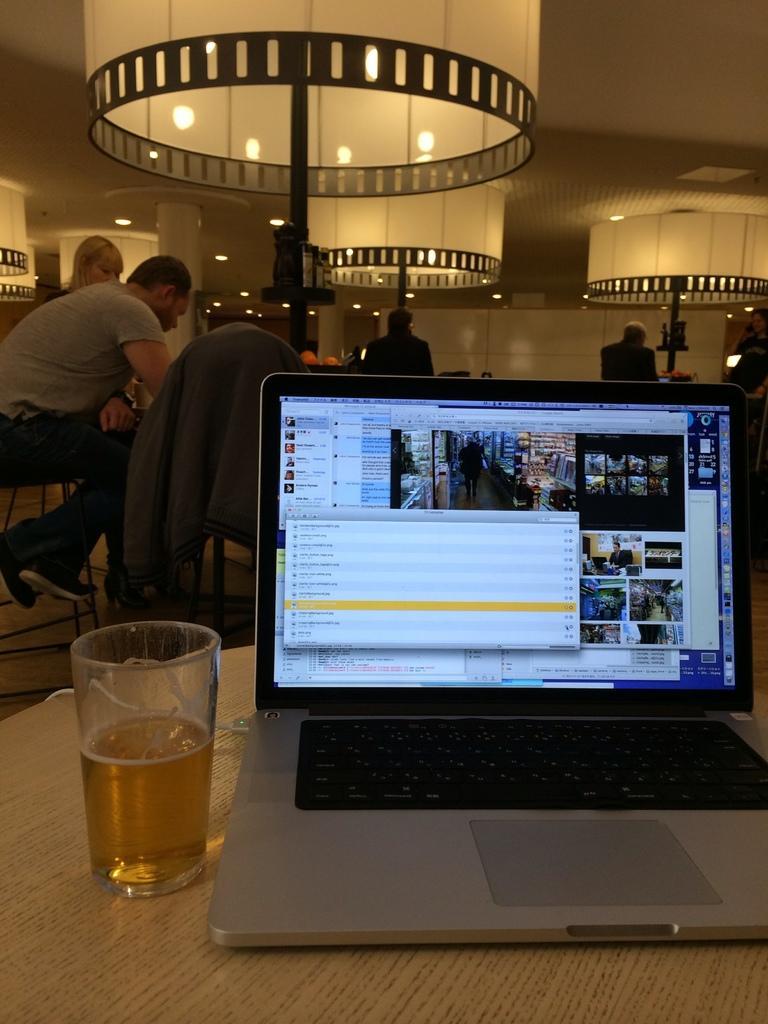How would you summarize this image in a sentence or two? This picture describes about group of people, few are seated and few are standing, in the middle of the image we can see a laptop and a glass on the table, in the background we can find few lights. 